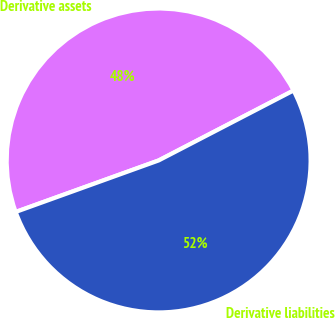Convert chart. <chart><loc_0><loc_0><loc_500><loc_500><pie_chart><fcel>Derivative assets<fcel>Derivative liabilities<nl><fcel>47.89%<fcel>52.11%<nl></chart> 